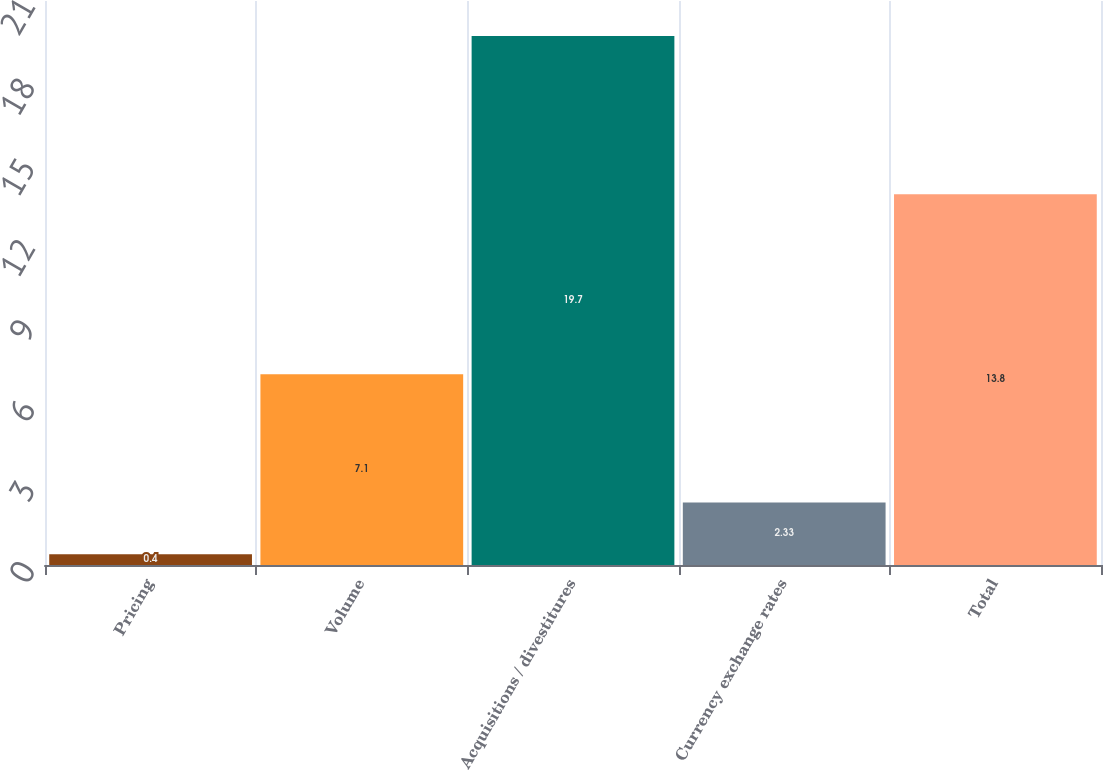Convert chart. <chart><loc_0><loc_0><loc_500><loc_500><bar_chart><fcel>Pricing<fcel>Volume<fcel>Acquisitions / divestitures<fcel>Currency exchange rates<fcel>Total<nl><fcel>0.4<fcel>7.1<fcel>19.7<fcel>2.33<fcel>13.8<nl></chart> 